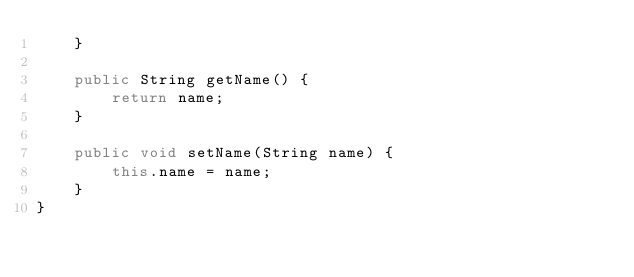<code> <loc_0><loc_0><loc_500><loc_500><_Java_>    }

    public String getName() {
        return name;
    }

    public void setName(String name) {
        this.name = name;
    }
}
</code> 